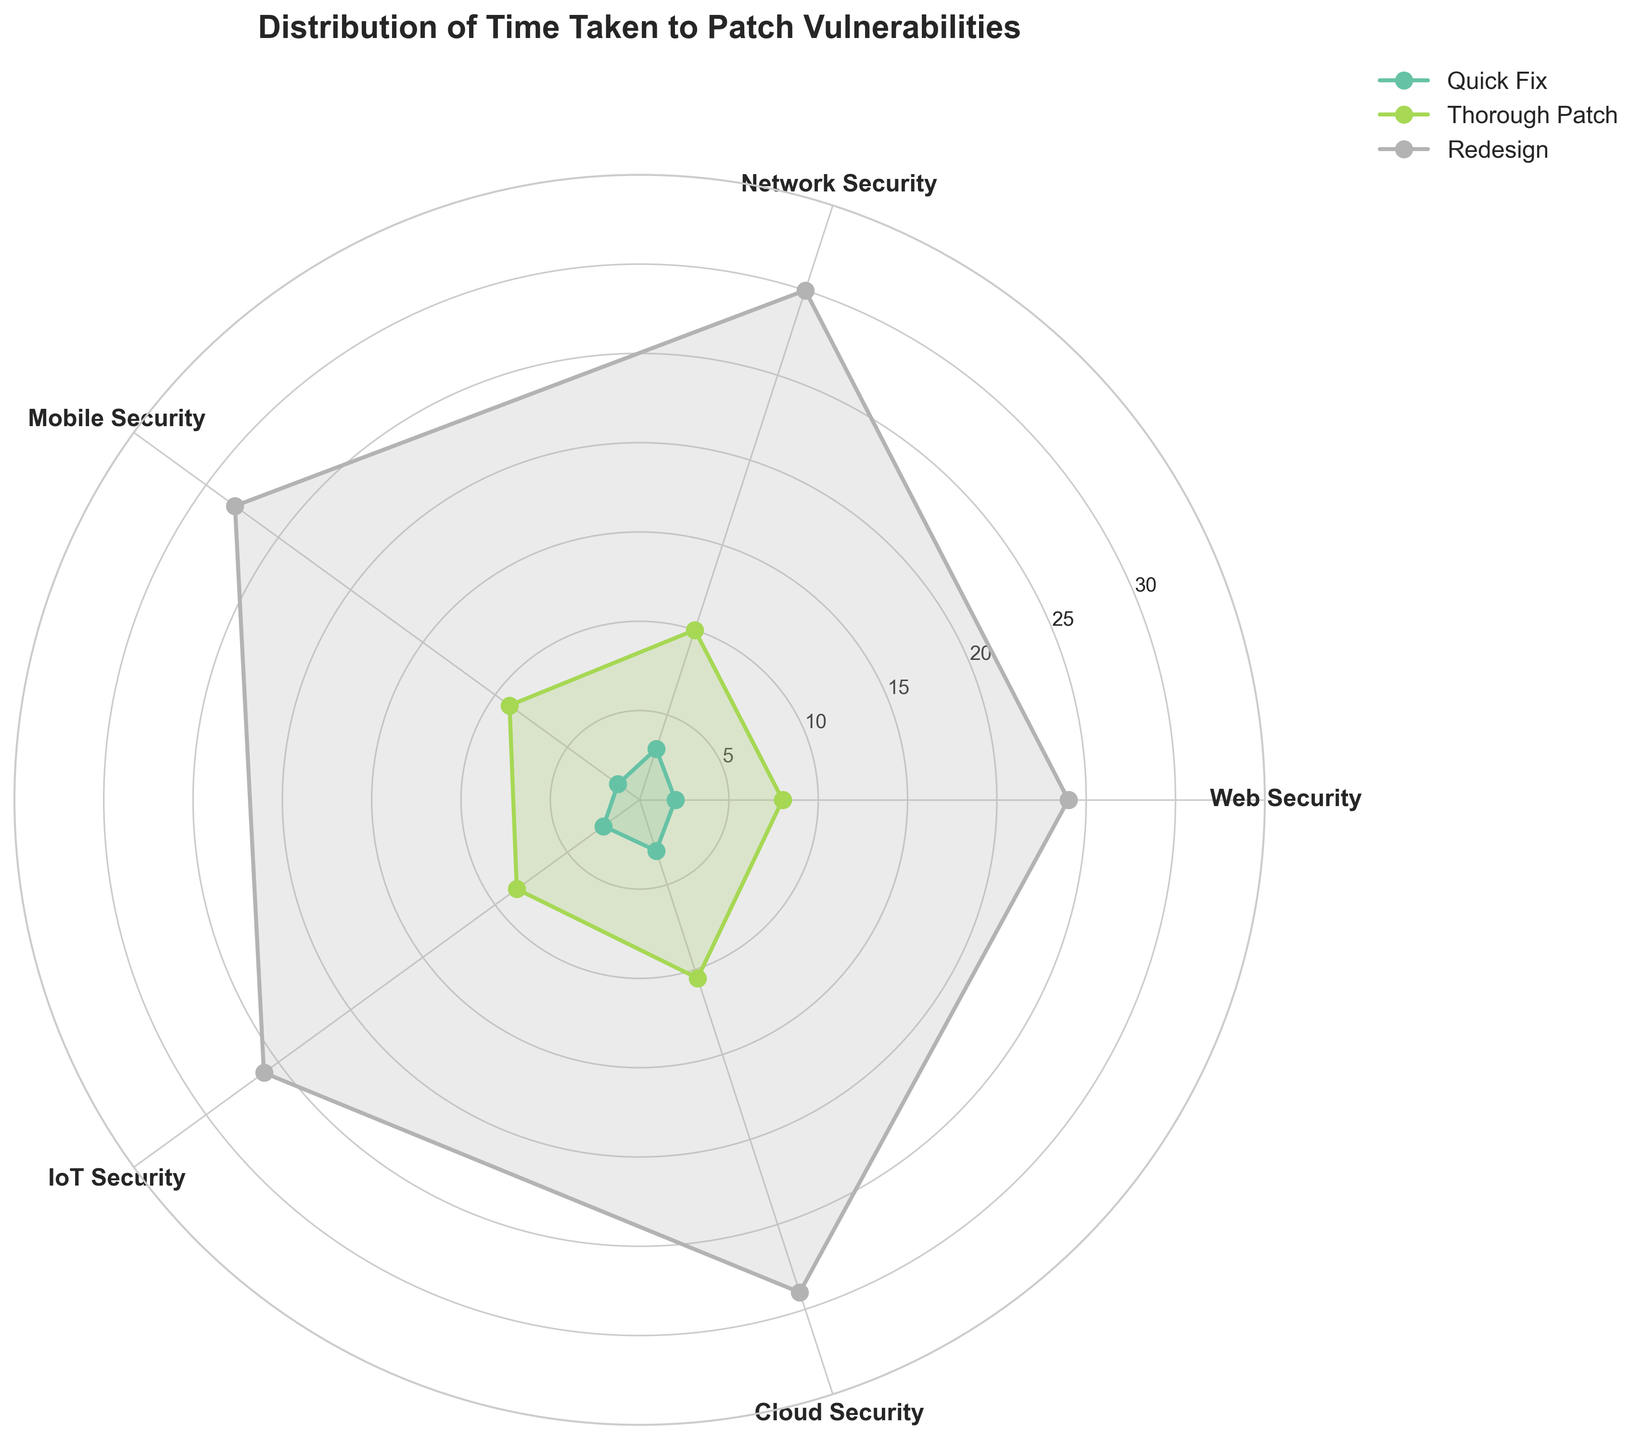Which type of fix has the shortest average time to patch vulnerabilities? To determine this, average the 'Time Taken (hours)' values for each fix type. Quick Fix has: (2 + 3 + 1.5 + 2.5 + 3)/5 = 2.4 hours. Thorough Patch has: (8 + 10 + 9 + 8.5 + 10.5)/5 = 9.2 hours. Redesign has: (24 + 30 + 28 + 26 + 29)/5 = 27.4 hours. Therefore, Quick Fix has the shortest average time.
Answer: Quick Fix What is the total time taken to apply 'Thorough Patches' across all categories? Sum the 'Time Taken (hours)' values for the Thorough Patch type: 8 + 10 + 9 + 8.5 + 10.5 = 46
Answer: 46 hours Compare the time taken for 'Quick Fix' and 'Redesign' in the 'Cloud Security' category. Which one is faster, and by how much? For Cloud Security, Quick Fix takes 3 hours and Redesign takes 29 hours. The difference is 29 - 3 = 26 hours. Quick Fix is faster by 26 hours.
Answer: Quick Fix, 26 hours What are the peak and lowest 'Time Taken' values for 'IoT Security' patches? IoT Security has Quick Fix: 2.5 hours, Thorough Patch: 8.5 hours, and Redesign: 26 hours. The peak is 26 hours, and the lowest is 2.5 hours.
Answer: Peak: 26 hours, Lowest: 2.5 hours Which category has the highest 'Time Taken' value among all patch types? Look across all the patch types to find the maximum values: Quick Fixes: 3 hours, Thorough Patches: 10.5 hours, Redesigns: 30 hours. The highest is 30 hours for Network Security in Redesign.
Answer: Network Security, 30 hours What is the median time taken across all 'Thorough Patch' fixes? Arrange the Thorough Patch times: [8, 8.5, 9, 10, 10.5]. The median value is the middle one: 9 hours.
Answer: 9 hours How does the average time of a 'Quick Fix' compare to a 'Thorough Patch' in the 'Web Security' category? The 'Web Security' times are: Quick Fix: 2 hours, Thorough Patch: 8 hours. Average time for Quick Fix is 2 and Thorough Patch is 8. Quick Fix is 6 hours faster than Thorough Patch.
Answer: Quick Fix, 6 hours Are the 'Time Taken' values for 'Mobile Security' patches generally higher or lower than for 'IoT Security' patches? Compare Mobile Security times (Quick Fix: 1.5, Thorough Patch: 9, Redesign: 28) to IoT Security times (Quick Fix: 2.5, Thorough Patch: 8.5, Redesign: 26). Mobile Security has 1.5 < 2.5 and 9 > 8.5 and 28 > 26, thus values are mixed but slightly higher overall.
Answer: Slightly higher 